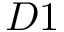Convert formula to latex. <formula><loc_0><loc_0><loc_500><loc_500>D 1</formula> 